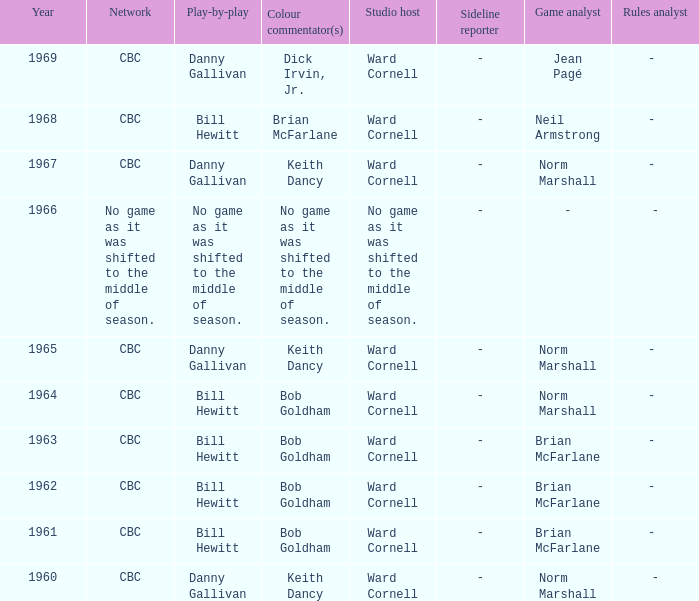Who did the play-by-play on the CBC network before 1961? Danny Gallivan. 